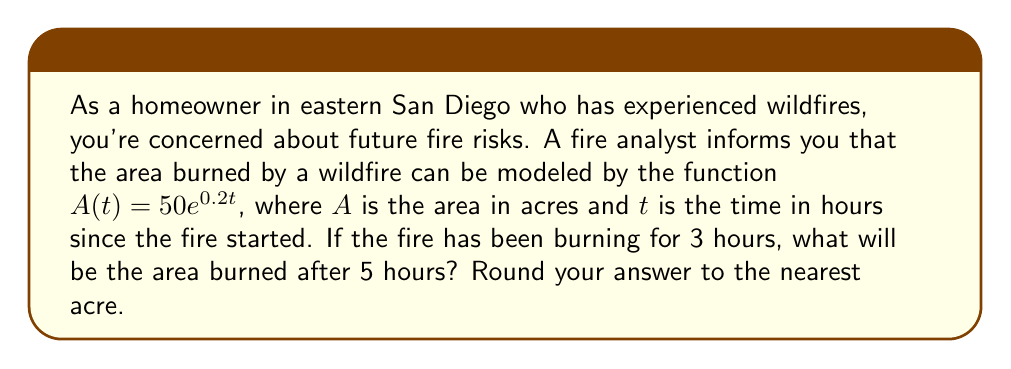Can you answer this question? Let's approach this problem step-by-step:

1) We're given the function $A(t) = 50e^{0.2t}$, where:
   - $A$ is the area burned in acres
   - $t$ is the time in hours since the fire started
   - $50$ is the initial area affected
   - $0.2$ is the growth rate

2) We need to find the difference between the area at $t=5$ and $t=3$.

3) Let's calculate the area at $t=3$:
   $A(3) = 50e^{0.2(3)} = 50e^{0.6} \approx 91.82$ acres

4) Now, let's calculate the area at $t=5$:
   $A(5) = 50e^{0.2(5)} = 50e^{1} \approx 135.91$ acres

5) The difference in area is:
   $A(5) - A(3) = 135.91 - 91.82 = 44.09$ acres

6) Rounding to the nearest acre, we get 44 acres.

This exponential growth model demonstrates how quickly wildfires can spread, underscoring the importance of early detection and rapid response in fire-prone areas like eastern San Diego.
Answer: 44 acres 